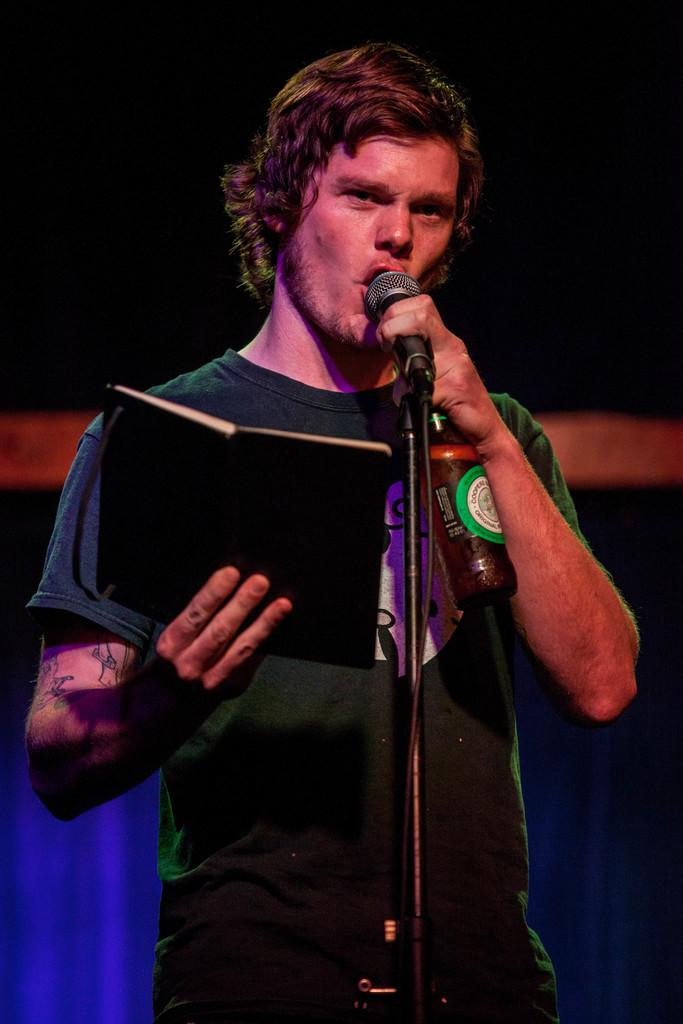What is the man in the image holding in one hand? The man is holding a book in one hand. What else is the man holding in the other hand? The man is holding a bottle in one hand and a microphone in the other hand. What is the man doing with the microphone? The man is talking on the microphone. What type of curve can be seen in the image? There is no curve present in the image. Is there a fight happening in the image? There is no fight depicted in the image. 